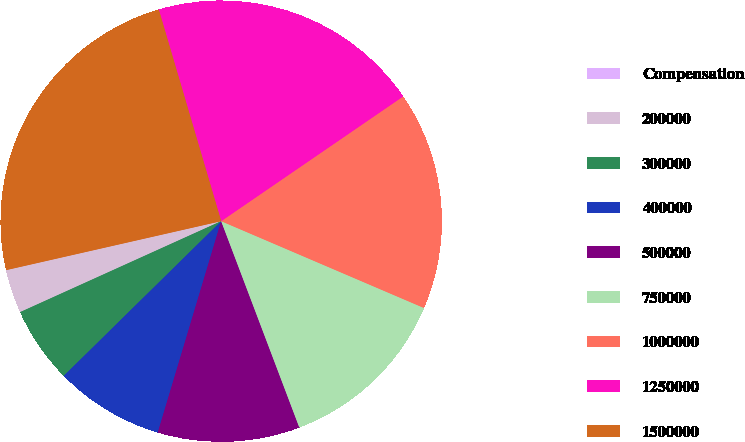Convert chart. <chart><loc_0><loc_0><loc_500><loc_500><pie_chart><fcel>Compensation<fcel>200000<fcel>300000<fcel>400000<fcel>500000<fcel>750000<fcel>1000000<fcel>1250000<fcel>1500000<nl><fcel>0.0%<fcel>3.2%<fcel>5.6%<fcel>8.0%<fcel>10.4%<fcel>12.8%<fcel>16.0%<fcel>20.0%<fcel>24.0%<nl></chart> 